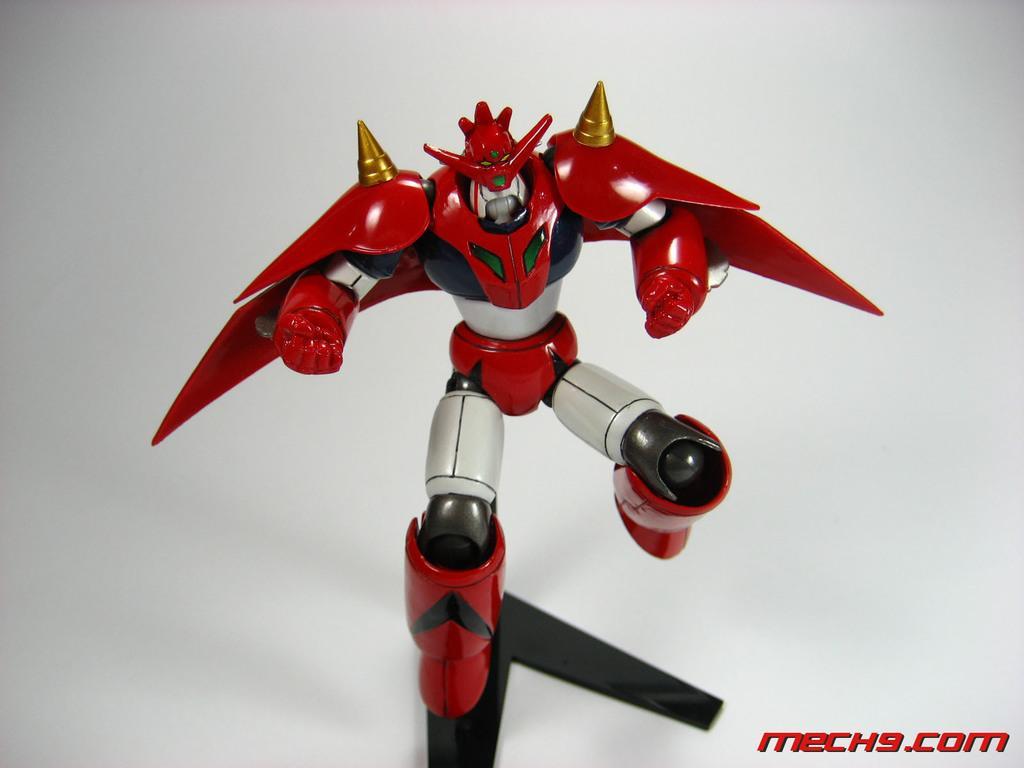Describe this image in one or two sentences. In this image I can see a robot, text and ash color background. 